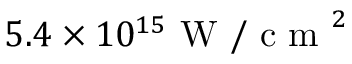Convert formula to latex. <formula><loc_0><loc_0><loc_500><loc_500>5 . 4 \times 1 0 ^ { 1 5 } W / c m ^ { 2 }</formula> 